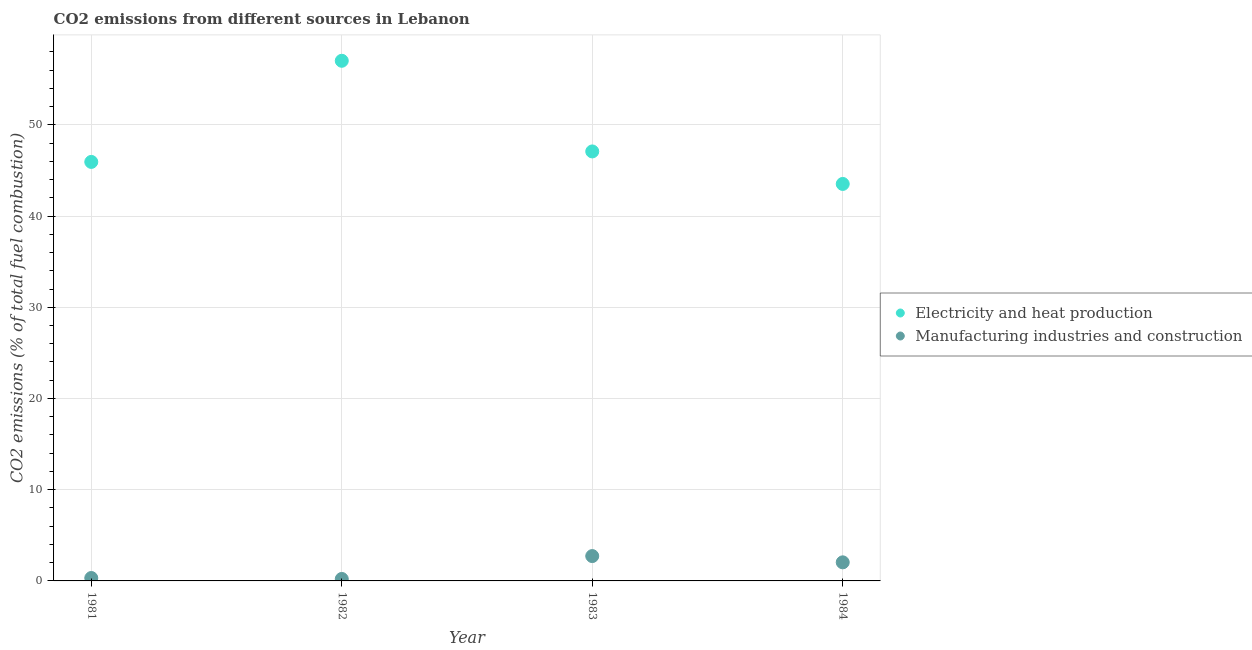What is the co2 emissions due to manufacturing industries in 1982?
Provide a short and direct response. 0.22. Across all years, what is the maximum co2 emissions due to manufacturing industries?
Ensure brevity in your answer.  2.72. Across all years, what is the minimum co2 emissions due to manufacturing industries?
Provide a short and direct response. 0.22. In which year was the co2 emissions due to electricity and heat production maximum?
Your answer should be compact. 1982. In which year was the co2 emissions due to electricity and heat production minimum?
Provide a short and direct response. 1984. What is the total co2 emissions due to manufacturing industries in the graph?
Your answer should be compact. 5.3. What is the difference between the co2 emissions due to electricity and heat production in 1981 and that in 1982?
Offer a terse response. -11.09. What is the difference between the co2 emissions due to electricity and heat production in 1982 and the co2 emissions due to manufacturing industries in 1984?
Offer a terse response. 54.98. What is the average co2 emissions due to electricity and heat production per year?
Provide a short and direct response. 48.39. In the year 1983, what is the difference between the co2 emissions due to manufacturing industries and co2 emissions due to electricity and heat production?
Offer a very short reply. -44.36. What is the ratio of the co2 emissions due to electricity and heat production in 1982 to that in 1984?
Make the answer very short. 1.31. Is the co2 emissions due to manufacturing industries in 1981 less than that in 1984?
Offer a terse response. Yes. What is the difference between the highest and the second highest co2 emissions due to manufacturing industries?
Your answer should be compact. 0.69. What is the difference between the highest and the lowest co2 emissions due to electricity and heat production?
Your answer should be compact. 13.5. In how many years, is the co2 emissions due to manufacturing industries greater than the average co2 emissions due to manufacturing industries taken over all years?
Ensure brevity in your answer.  2. Is the sum of the co2 emissions due to electricity and heat production in 1981 and 1983 greater than the maximum co2 emissions due to manufacturing industries across all years?
Keep it short and to the point. Yes. Is the co2 emissions due to electricity and heat production strictly less than the co2 emissions due to manufacturing industries over the years?
Provide a short and direct response. No. How many dotlines are there?
Offer a terse response. 2. How many years are there in the graph?
Offer a terse response. 4. What is the difference between two consecutive major ticks on the Y-axis?
Offer a very short reply. 10. What is the title of the graph?
Make the answer very short. CO2 emissions from different sources in Lebanon. Does "Working capital" appear as one of the legend labels in the graph?
Give a very brief answer. No. What is the label or title of the Y-axis?
Offer a terse response. CO2 emissions (% of total fuel combustion). What is the CO2 emissions (% of total fuel combustion) in Electricity and heat production in 1981?
Provide a succinct answer. 45.93. What is the CO2 emissions (% of total fuel combustion) of Manufacturing industries and construction in 1981?
Make the answer very short. 0.32. What is the CO2 emissions (% of total fuel combustion) in Electricity and heat production in 1982?
Give a very brief answer. 57.02. What is the CO2 emissions (% of total fuel combustion) in Manufacturing industries and construction in 1982?
Provide a short and direct response. 0.22. What is the CO2 emissions (% of total fuel combustion) of Electricity and heat production in 1983?
Ensure brevity in your answer.  47.08. What is the CO2 emissions (% of total fuel combustion) in Manufacturing industries and construction in 1983?
Provide a succinct answer. 2.72. What is the CO2 emissions (% of total fuel combustion) of Electricity and heat production in 1984?
Keep it short and to the point. 43.52. What is the CO2 emissions (% of total fuel combustion) in Manufacturing industries and construction in 1984?
Give a very brief answer. 2.04. Across all years, what is the maximum CO2 emissions (% of total fuel combustion) of Electricity and heat production?
Your response must be concise. 57.02. Across all years, what is the maximum CO2 emissions (% of total fuel combustion) in Manufacturing industries and construction?
Provide a succinct answer. 2.72. Across all years, what is the minimum CO2 emissions (% of total fuel combustion) in Electricity and heat production?
Provide a short and direct response. 43.52. Across all years, what is the minimum CO2 emissions (% of total fuel combustion) of Manufacturing industries and construction?
Your response must be concise. 0.22. What is the total CO2 emissions (% of total fuel combustion) of Electricity and heat production in the graph?
Your answer should be compact. 193.55. What is the total CO2 emissions (% of total fuel combustion) in Manufacturing industries and construction in the graph?
Keep it short and to the point. 5.3. What is the difference between the CO2 emissions (% of total fuel combustion) of Electricity and heat production in 1981 and that in 1982?
Offer a very short reply. -11.09. What is the difference between the CO2 emissions (% of total fuel combustion) in Manufacturing industries and construction in 1981 and that in 1982?
Your answer should be compact. 0.1. What is the difference between the CO2 emissions (% of total fuel combustion) in Electricity and heat production in 1981 and that in 1983?
Make the answer very short. -1.15. What is the difference between the CO2 emissions (% of total fuel combustion) in Manufacturing industries and construction in 1981 and that in 1983?
Offer a very short reply. -2.4. What is the difference between the CO2 emissions (% of total fuel combustion) in Electricity and heat production in 1981 and that in 1984?
Your answer should be compact. 2.41. What is the difference between the CO2 emissions (% of total fuel combustion) in Manufacturing industries and construction in 1981 and that in 1984?
Make the answer very short. -1.72. What is the difference between the CO2 emissions (% of total fuel combustion) in Electricity and heat production in 1982 and that in 1983?
Provide a short and direct response. 9.94. What is the difference between the CO2 emissions (% of total fuel combustion) of Manufacturing industries and construction in 1982 and that in 1983?
Provide a short and direct response. -2.51. What is the difference between the CO2 emissions (% of total fuel combustion) in Electricity and heat production in 1982 and that in 1984?
Give a very brief answer. 13.5. What is the difference between the CO2 emissions (% of total fuel combustion) of Manufacturing industries and construction in 1982 and that in 1984?
Ensure brevity in your answer.  -1.82. What is the difference between the CO2 emissions (% of total fuel combustion) in Electricity and heat production in 1983 and that in 1984?
Your answer should be compact. 3.56. What is the difference between the CO2 emissions (% of total fuel combustion) of Manufacturing industries and construction in 1983 and that in 1984?
Your response must be concise. 0.69. What is the difference between the CO2 emissions (% of total fuel combustion) of Electricity and heat production in 1981 and the CO2 emissions (% of total fuel combustion) of Manufacturing industries and construction in 1982?
Provide a short and direct response. 45.72. What is the difference between the CO2 emissions (% of total fuel combustion) in Electricity and heat production in 1981 and the CO2 emissions (% of total fuel combustion) in Manufacturing industries and construction in 1983?
Offer a very short reply. 43.21. What is the difference between the CO2 emissions (% of total fuel combustion) in Electricity and heat production in 1981 and the CO2 emissions (% of total fuel combustion) in Manufacturing industries and construction in 1984?
Offer a terse response. 43.9. What is the difference between the CO2 emissions (% of total fuel combustion) in Electricity and heat production in 1982 and the CO2 emissions (% of total fuel combustion) in Manufacturing industries and construction in 1983?
Offer a very short reply. 54.3. What is the difference between the CO2 emissions (% of total fuel combustion) of Electricity and heat production in 1982 and the CO2 emissions (% of total fuel combustion) of Manufacturing industries and construction in 1984?
Ensure brevity in your answer.  54.98. What is the difference between the CO2 emissions (% of total fuel combustion) in Electricity and heat production in 1983 and the CO2 emissions (% of total fuel combustion) in Manufacturing industries and construction in 1984?
Offer a terse response. 45.04. What is the average CO2 emissions (% of total fuel combustion) in Electricity and heat production per year?
Ensure brevity in your answer.  48.39. What is the average CO2 emissions (% of total fuel combustion) in Manufacturing industries and construction per year?
Provide a short and direct response. 1.32. In the year 1981, what is the difference between the CO2 emissions (% of total fuel combustion) in Electricity and heat production and CO2 emissions (% of total fuel combustion) in Manufacturing industries and construction?
Your answer should be compact. 45.61. In the year 1982, what is the difference between the CO2 emissions (% of total fuel combustion) in Electricity and heat production and CO2 emissions (% of total fuel combustion) in Manufacturing industries and construction?
Your response must be concise. 56.8. In the year 1983, what is the difference between the CO2 emissions (% of total fuel combustion) in Electricity and heat production and CO2 emissions (% of total fuel combustion) in Manufacturing industries and construction?
Ensure brevity in your answer.  44.36. In the year 1984, what is the difference between the CO2 emissions (% of total fuel combustion) in Electricity and heat production and CO2 emissions (% of total fuel combustion) in Manufacturing industries and construction?
Give a very brief answer. 41.48. What is the ratio of the CO2 emissions (% of total fuel combustion) in Electricity and heat production in 1981 to that in 1982?
Ensure brevity in your answer.  0.81. What is the ratio of the CO2 emissions (% of total fuel combustion) in Manufacturing industries and construction in 1981 to that in 1982?
Your answer should be very brief. 1.48. What is the ratio of the CO2 emissions (% of total fuel combustion) of Electricity and heat production in 1981 to that in 1983?
Offer a very short reply. 0.98. What is the ratio of the CO2 emissions (% of total fuel combustion) of Manufacturing industries and construction in 1981 to that in 1983?
Provide a succinct answer. 0.12. What is the ratio of the CO2 emissions (% of total fuel combustion) in Electricity and heat production in 1981 to that in 1984?
Offer a very short reply. 1.06. What is the ratio of the CO2 emissions (% of total fuel combustion) in Manufacturing industries and construction in 1981 to that in 1984?
Ensure brevity in your answer.  0.16. What is the ratio of the CO2 emissions (% of total fuel combustion) of Electricity and heat production in 1982 to that in 1983?
Give a very brief answer. 1.21. What is the ratio of the CO2 emissions (% of total fuel combustion) of Manufacturing industries and construction in 1982 to that in 1983?
Provide a short and direct response. 0.08. What is the ratio of the CO2 emissions (% of total fuel combustion) of Electricity and heat production in 1982 to that in 1984?
Give a very brief answer. 1.31. What is the ratio of the CO2 emissions (% of total fuel combustion) in Manufacturing industries and construction in 1982 to that in 1984?
Your answer should be compact. 0.11. What is the ratio of the CO2 emissions (% of total fuel combustion) in Electricity and heat production in 1983 to that in 1984?
Provide a short and direct response. 1.08. What is the ratio of the CO2 emissions (% of total fuel combustion) in Manufacturing industries and construction in 1983 to that in 1984?
Offer a terse response. 1.34. What is the difference between the highest and the second highest CO2 emissions (% of total fuel combustion) in Electricity and heat production?
Make the answer very short. 9.94. What is the difference between the highest and the second highest CO2 emissions (% of total fuel combustion) of Manufacturing industries and construction?
Make the answer very short. 0.69. What is the difference between the highest and the lowest CO2 emissions (% of total fuel combustion) of Electricity and heat production?
Your answer should be compact. 13.5. What is the difference between the highest and the lowest CO2 emissions (% of total fuel combustion) of Manufacturing industries and construction?
Offer a terse response. 2.51. 